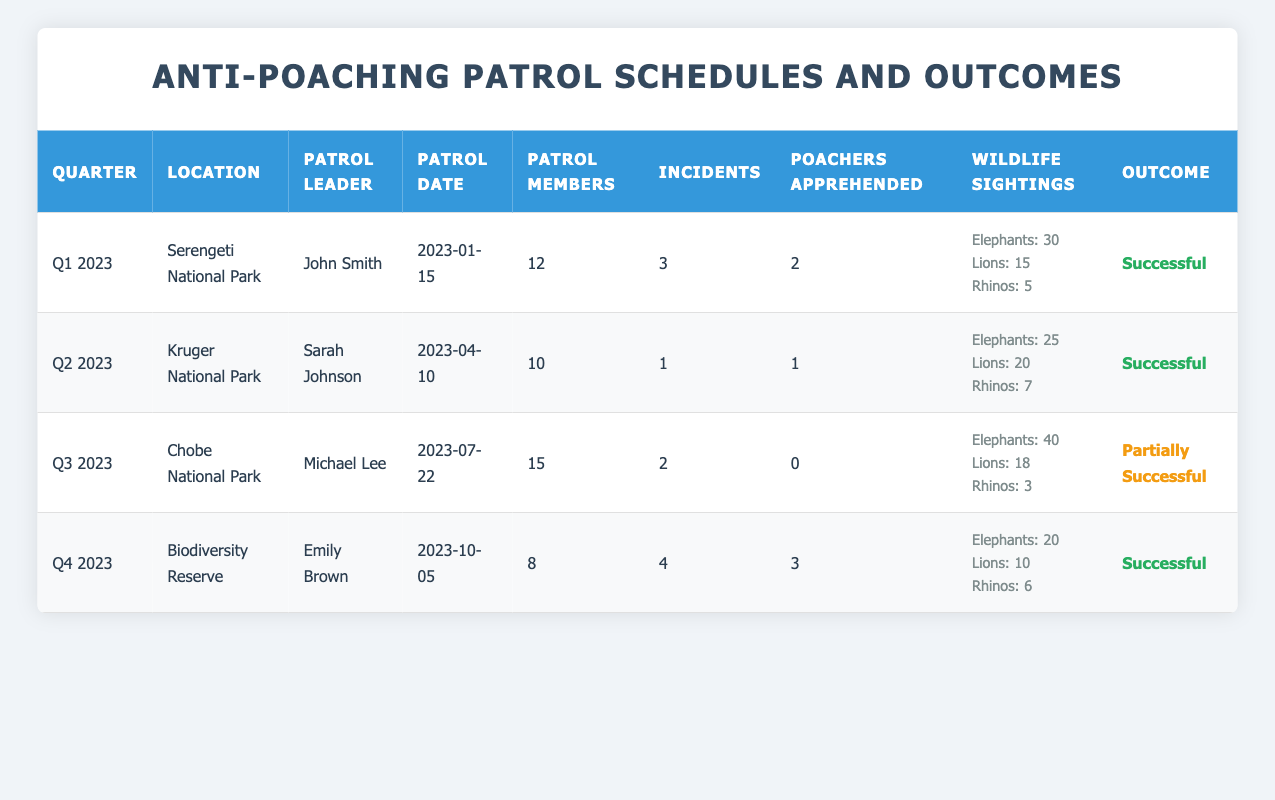What was the location of the patrol in Q4 2023? In the table, you can directly find the entry for Q4 2023, which shows the location as "Biodiversity Reserve."
Answer: Biodiversity Reserve How many poachers were apprehended in Q3 2023? Referring to the Q3 2023 entry in the table, the number of poachers apprehended is listed as 0.
Answer: 0 What is the total number of incidents reported across all patrols? By looking at the table, we sum the incidents reported: 3 (Q1) + 1 (Q2) + 2 (Q3) + 4 (Q4) = 10.
Answer: 10 Which patrol had the highest number of wildlife sightings? To find this, we check the wildlife sightings data: Q1 has 30 elephants, Q2 has 25, Q3 has 40, and Q4 has 20. Q3, with 40 elephants, has the highest wildlife sightings.
Answer: Q3 2023 Was the patrol in Kruger National Park successful? In the Q2 2023 row, the outcome is listed as "Successful," indicating that the patrol achieved its objectives.
Answer: Yes What is the average number of patrol members per quarter? We add the number of patrol members: 12 (Q1) + 10 (Q2) + 15 (Q3) + 8 (Q4) = 45. There are 4 quarters, so the average is 45/4 = 11.25.
Answer: 11.25 Which quarter had the least number of poachers apprehended? Looking at the poachers apprehended data, Q1 (2), Q2 (1), Q3 (0), Q4 (3). Q3 had the least, with 0 poachers apprehended.
Answer: Q3 2023 Was the outcome for all patrols successful? Checking the outcomes: Q1 (Successful), Q2 (Successful), Q3 (Partially Successful), Q4 (Successful). Since Q3 was not fully successful, the answer is no.
Answer: No What quarter had the most patrol members? Among the entries, Q3 has 15 patrol members, which is the highest compared to Q1 (12), Q2 (10), and Q4 (8).
Answer: Q3 2023 